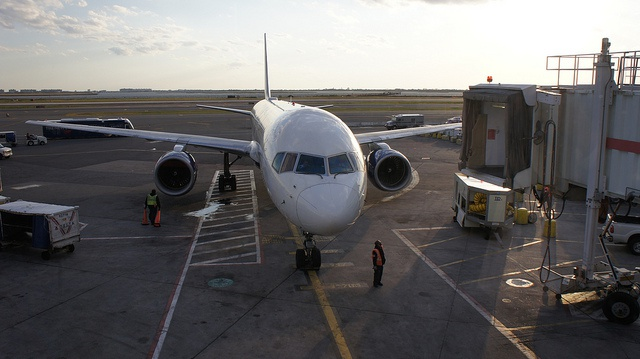Describe the objects in this image and their specific colors. I can see airplane in darkgray, black, and gray tones, truck in darkgray, black, and gray tones, truck in darkgray, black, gray, and purple tones, people in darkgray, black, maroon, and gray tones, and truck in darkgray, black, and gray tones in this image. 